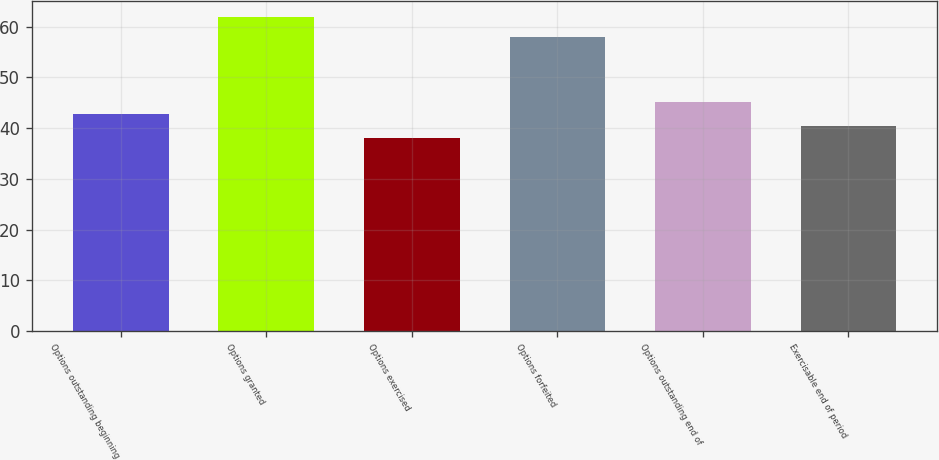Convert chart. <chart><loc_0><loc_0><loc_500><loc_500><bar_chart><fcel>Options outstanding beginning<fcel>Options granted<fcel>Options exercised<fcel>Options forfeited<fcel>Options outstanding end of<fcel>Exercisable end of period<nl><fcel>42.8<fcel>62<fcel>38<fcel>58<fcel>45.2<fcel>40.4<nl></chart> 